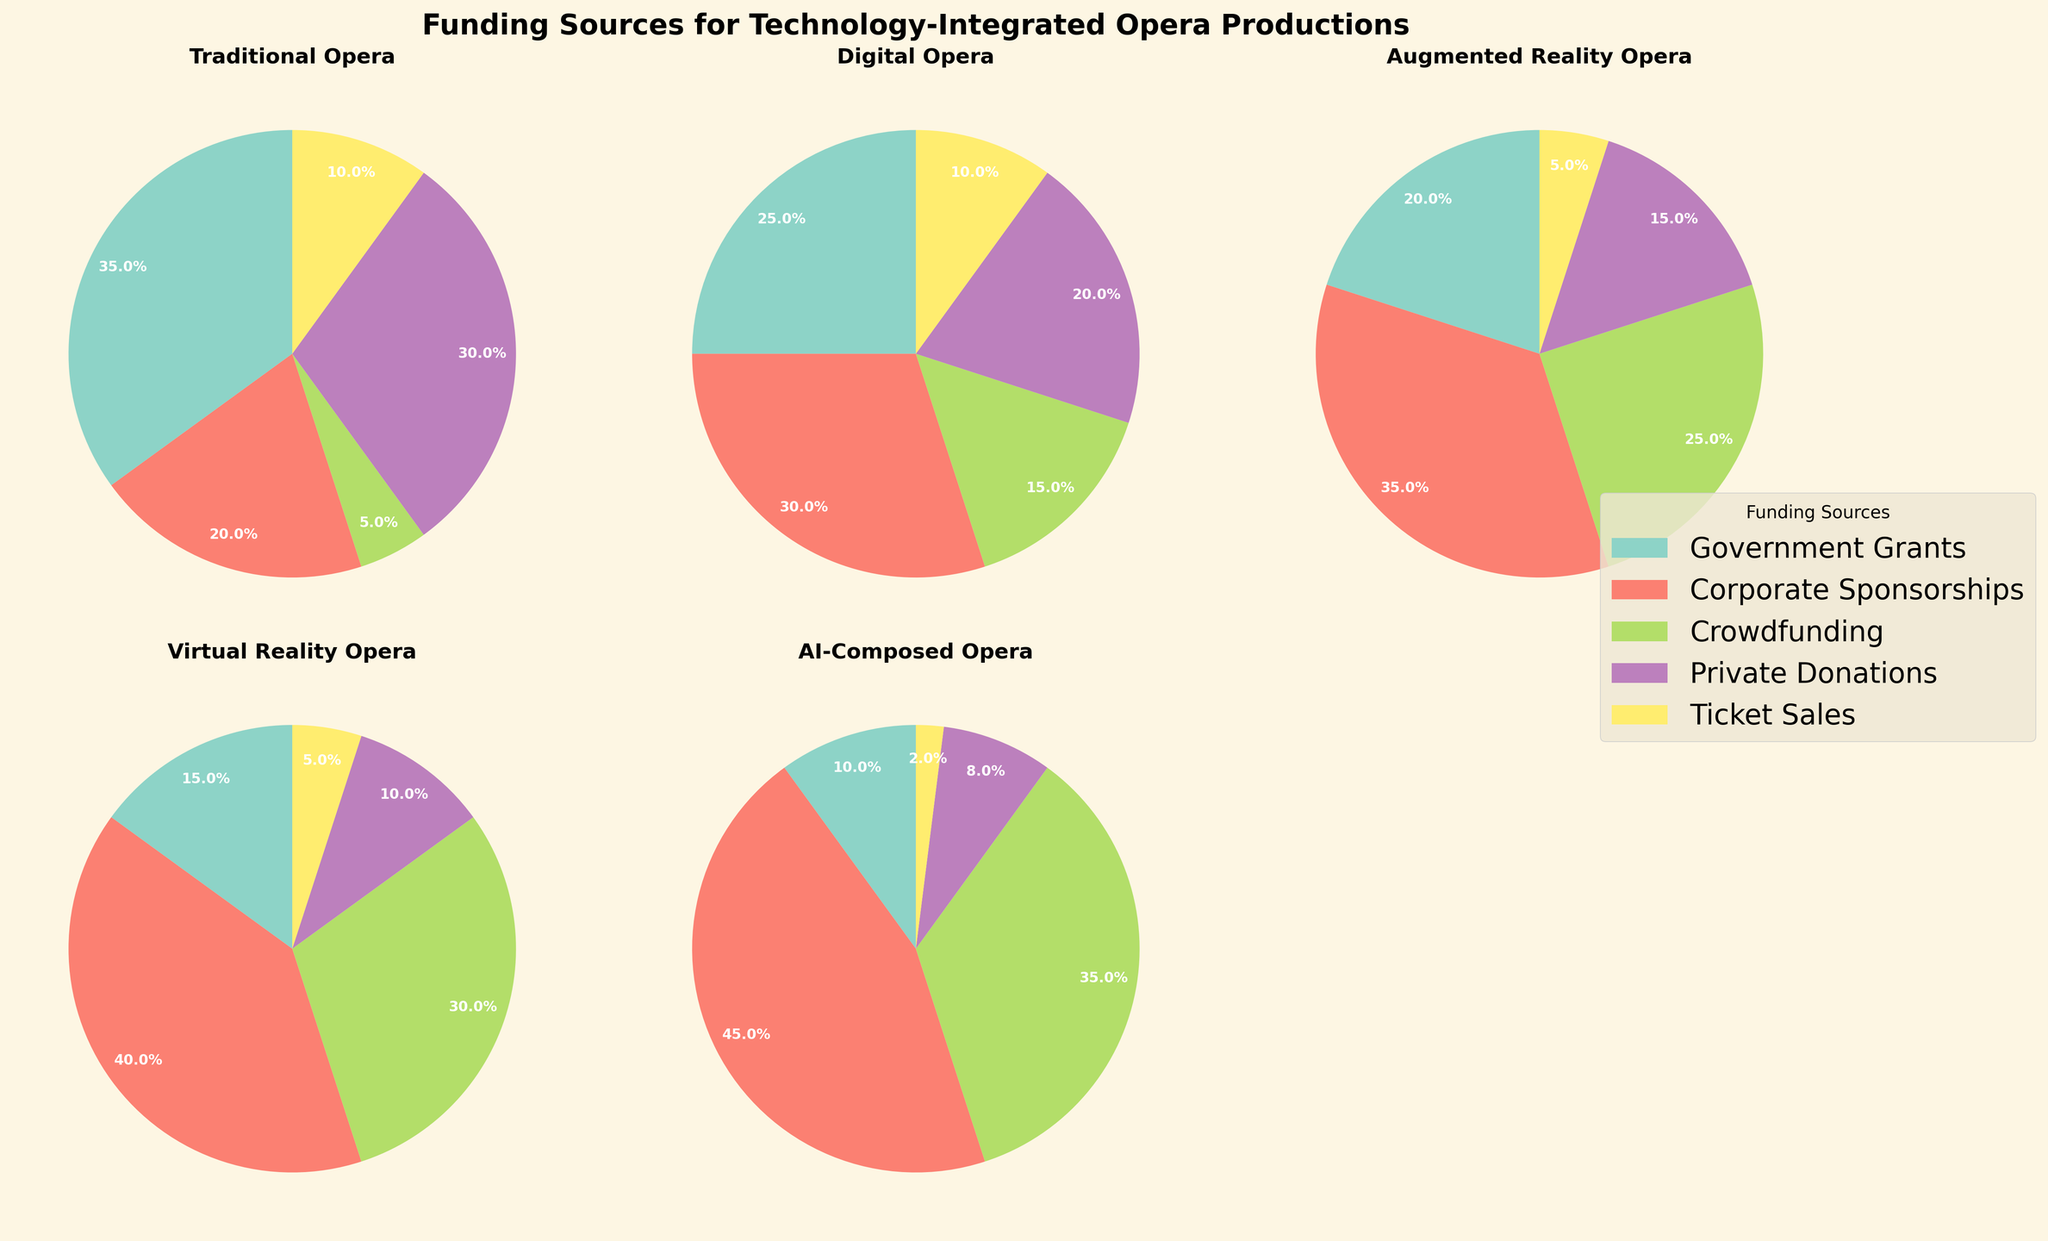What's the title of the figure? The title is displayed at the top of the figure in bold. It helps set the context for the visual data presented.
Answer: Funding Sources for Technology-Integrated Opera Productions Which funding source has the highest percentage in Traditional Opera? To determine the highest percentage, look at each slice of the Traditional Opera pie chart and see which funding source has the largest proportion.
Answer: Government Grants How many different funding types are represented in these pie charts? Count the number of subplots, noting that each subplot represents a distinct funding type. Ensure no subplots are missed.
Answer: 5 Which funding type relies most heavily on Corporate Sponsorships? Compare the Corporate Sponsorships slice in each pie chart to see which one has the largest percentage.
Answer: AI-Composed Opera What is the combined percentage of Private Donations and Ticket Sales for Augmented Reality Opera? Add the percentages of the slices for Private Donations and Ticket Sales in the Augmented Reality Opera subplot. The values are 15% and 5%, respectively, so compute 15% + 5%.
Answer: 20% Which two funding types have the same percentage for Ticket Sales? Identify the percentage of the Ticket Sales slice in each pie chart, and find the two funding types with matching values.
Answer: Digital Opera and Augmented Reality Opera How does the funding distribution for Virtual Reality Opera compare to Digital Opera in terms of Crowdfunding? Examine the size of the Crowdfunding slice in each pie chart and compare them directly.
Answer: Virtual Reality Opera has a higher percentage of Crowdfunding What is the sum of the percentages for Government Grants and Crowdfunding for AI-Composed Opera? Add the percentages of Government Grants (10%) and Crowdfunding (35%) slices in the AI-Composed Opera pie chart to find the total.
Answer: 45% Arrange the funding types in descending order based on their Corporate Sponsorships percentage. Review the Corporate Sponsorships slices of each pie chart and list them starting with the highest percentage to the lowest: 45% (AI-Composed Opera), 40% (Virtual Reality Opera), 35% (Augmented Reality Opera), 30% (Digital Opera), 20% (Traditional Opera).
Answer: AI-Composed Opera, Virtual Reality Opera, Augmented Reality Opera, Digital Opera, Traditional Opera Which funding type has the least reliance on Private Donations? Compare the proportions of Private Donations in all the pie charts and identify the smallest slice.
Answer: AI-Composed Opera 